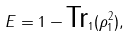Convert formula to latex. <formula><loc_0><loc_0><loc_500><loc_500>E = 1 - \text {Tr} _ { 1 } ( \rho _ { 1 } ^ { 2 } ) ,</formula> 